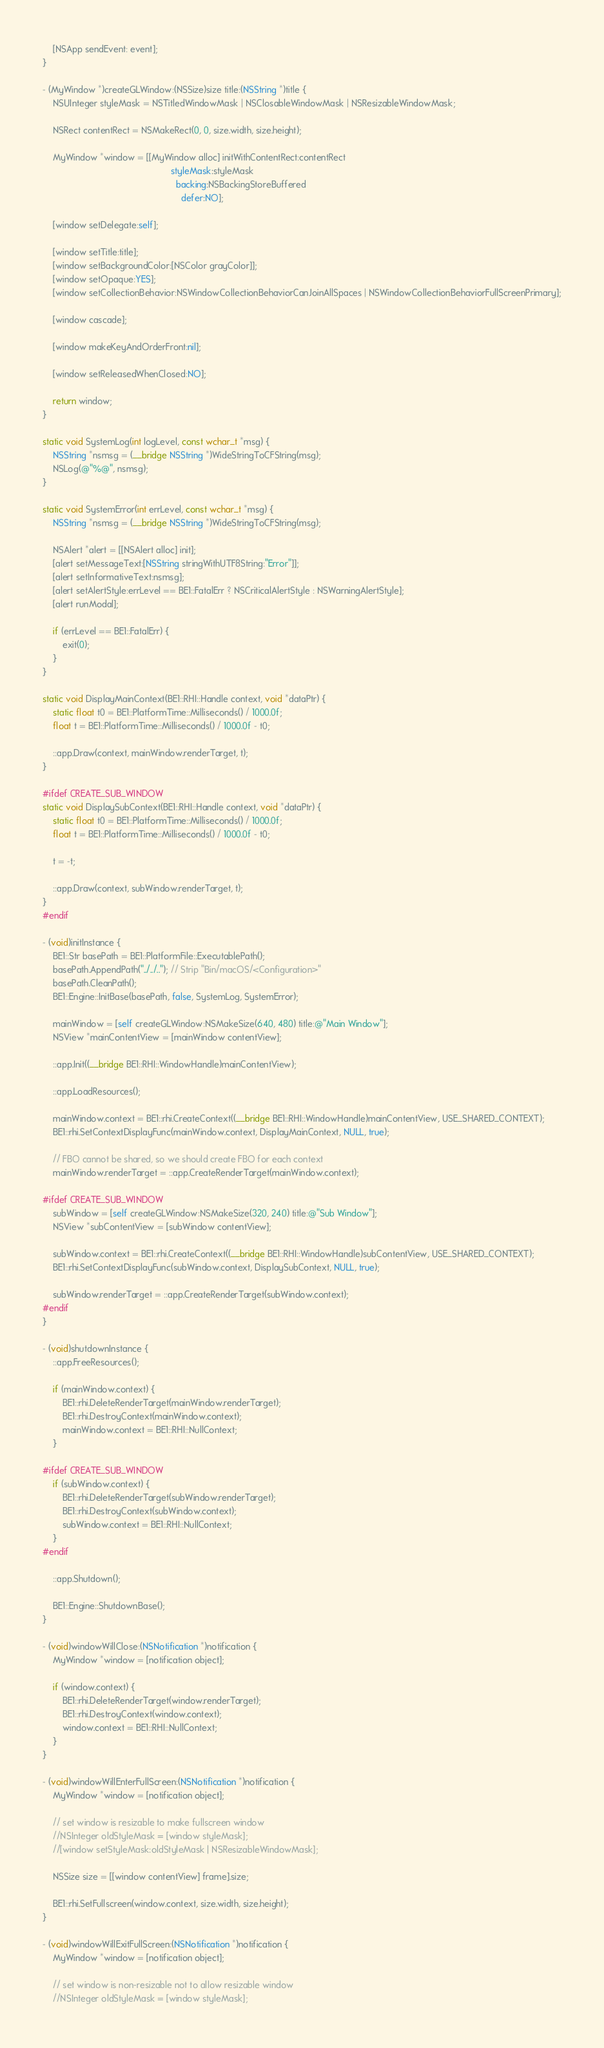<code> <loc_0><loc_0><loc_500><loc_500><_ObjectiveC_>    [NSApp sendEvent: event];
}

- (MyWindow *)createGLWindow:(NSSize)size title:(NSString *)title {
    NSUInteger styleMask = NSTitledWindowMask | NSClosableWindowMask | NSResizableWindowMask;
    
    NSRect contentRect = NSMakeRect(0, 0, size.width, size.height);
    
    MyWindow *window = [[MyWindow alloc] initWithContentRect:contentRect
                                                   styleMask:styleMask
                                                     backing:NSBackingStoreBuffered
                                                       defer:NO];
    
    [window setDelegate:self];
    
    [window setTitle:title];
    [window setBackgroundColor:[NSColor grayColor]];
    [window setOpaque:YES];
    [window setCollectionBehavior:NSWindowCollectionBehaviorCanJoinAllSpaces | NSWindowCollectionBehaviorFullScreenPrimary];
    
    [window cascade];
    
    [window makeKeyAndOrderFront:nil];
    
    [window setReleasedWhenClosed:NO];
    
    return window;
}

static void SystemLog(int logLevel, const wchar_t *msg) {
    NSString *nsmsg = (__bridge NSString *)WideStringToCFString(msg);
    NSLog(@"%@", nsmsg);
}

static void SystemError(int errLevel, const wchar_t *msg) {
    NSString *nsmsg = (__bridge NSString *)WideStringToCFString(msg);
    
    NSAlert *alert = [[NSAlert alloc] init];
    [alert setMessageText:[NSString stringWithUTF8String:"Error"]];
    [alert setInformativeText:nsmsg];
    [alert setAlertStyle:errLevel == BE1::FatalErr ? NSCriticalAlertStyle : NSWarningAlertStyle];
    [alert runModal];
    
    if (errLevel == BE1::FatalErr) {
        exit(0);
    }
}

static void DisplayMainContext(BE1::RHI::Handle context, void *dataPtr) {
    static float t0 = BE1::PlatformTime::Milliseconds() / 1000.0f;
    float t = BE1::PlatformTime::Milliseconds() / 1000.0f - t0;
    
    ::app.Draw(context, mainWindow.renderTarget, t);
}

#ifdef CREATE_SUB_WINDOW
static void DisplaySubContext(BE1::RHI::Handle context, void *dataPtr) {
    static float t0 = BE1::PlatformTime::Milliseconds() / 1000.0f;
    float t = BE1::PlatformTime::Milliseconds() / 1000.0f - t0;
    
    t = -t;
    
    ::app.Draw(context, subWindow.renderTarget, t);
}
#endif

- (void)initInstance {
    BE1::Str basePath = BE1::PlatformFile::ExecutablePath();
    basePath.AppendPath("../../.."); // Strip "Bin/macOS/<Configuration>"
    basePath.CleanPath();
    BE1::Engine::InitBase(basePath, false, SystemLog, SystemError);
    
    mainWindow = [self createGLWindow:NSMakeSize(640, 480) title:@"Main Window"];
    NSView *mainContentView = [mainWindow contentView];

    ::app.Init((__bridge BE1::RHI::WindowHandle)mainContentView);
    
    ::app.LoadResources();
    
    mainWindow.context = BE1::rhi.CreateContext((__bridge BE1::RHI::WindowHandle)mainContentView, USE_SHARED_CONTEXT);    
    BE1::rhi.SetContextDisplayFunc(mainWindow.context, DisplayMainContext, NULL, true);
    
    // FBO cannot be shared, so we should create FBO for each context
    mainWindow.renderTarget = ::app.CreateRenderTarget(mainWindow.context);

#ifdef CREATE_SUB_WINDOW
    subWindow = [self createGLWindow:NSMakeSize(320, 240) title:@"Sub Window"];
    NSView *subContentView = [subWindow contentView];

    subWindow.context = BE1::rhi.CreateContext((__bridge BE1::RHI::WindowHandle)subContentView, USE_SHARED_CONTEXT);    
    BE1::rhi.SetContextDisplayFunc(subWindow.context, DisplaySubContext, NULL, true);

    subWindow.renderTarget = ::app.CreateRenderTarget(subWindow.context);
#endif
}

- (void)shutdownInstance {
    ::app.FreeResources();
    
    if (mainWindow.context) {
        BE1::rhi.DeleteRenderTarget(mainWindow.renderTarget);
        BE1::rhi.DestroyContext(mainWindow.context);
        mainWindow.context = BE1::RHI::NullContext;
    }
   
#ifdef CREATE_SUB_WINDOW
    if (subWindow.context) {
        BE1::rhi.DeleteRenderTarget(subWindow.renderTarget);
        BE1::rhi.DestroyContext(subWindow.context);
        subWindow.context = BE1::RHI::NullContext;
    }
#endif
    
    ::app.Shutdown();
    
    BE1::Engine::ShutdownBase();
}

- (void)windowWillClose:(NSNotification *)notification {
    MyWindow *window = [notification object];
    
    if (window.context) {
        BE1::rhi.DeleteRenderTarget(window.renderTarget);
        BE1::rhi.DestroyContext(window.context);
        window.context = BE1::RHI::NullContext;
    }
}

- (void)windowWillEnterFullScreen:(NSNotification *)notification {
    MyWindow *window = [notification object];
    
    // set window is resizable to make fullscreen window
    //NSInteger oldStyleMask = [window styleMask];
    //[window setStyleMask:oldStyleMask | NSResizableWindowMask];
    
    NSSize size = [[window contentView] frame].size;
    
    BE1::rhi.SetFullscreen(window.context, size.width, size.height);
}

- (void)windowWillExitFullScreen:(NSNotification *)notification {
    MyWindow *window = [notification object];
    
    // set window is non-resizable not to allow resizable window
    //NSInteger oldStyleMask = [window styleMask];</code> 